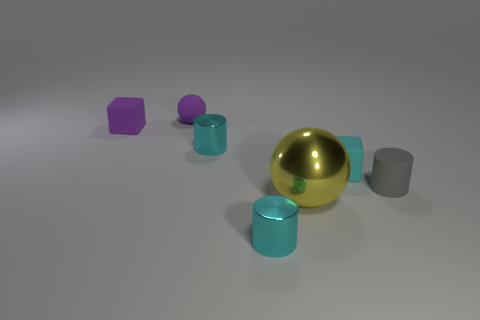How many tiny cubes have the same color as the large object? 0 